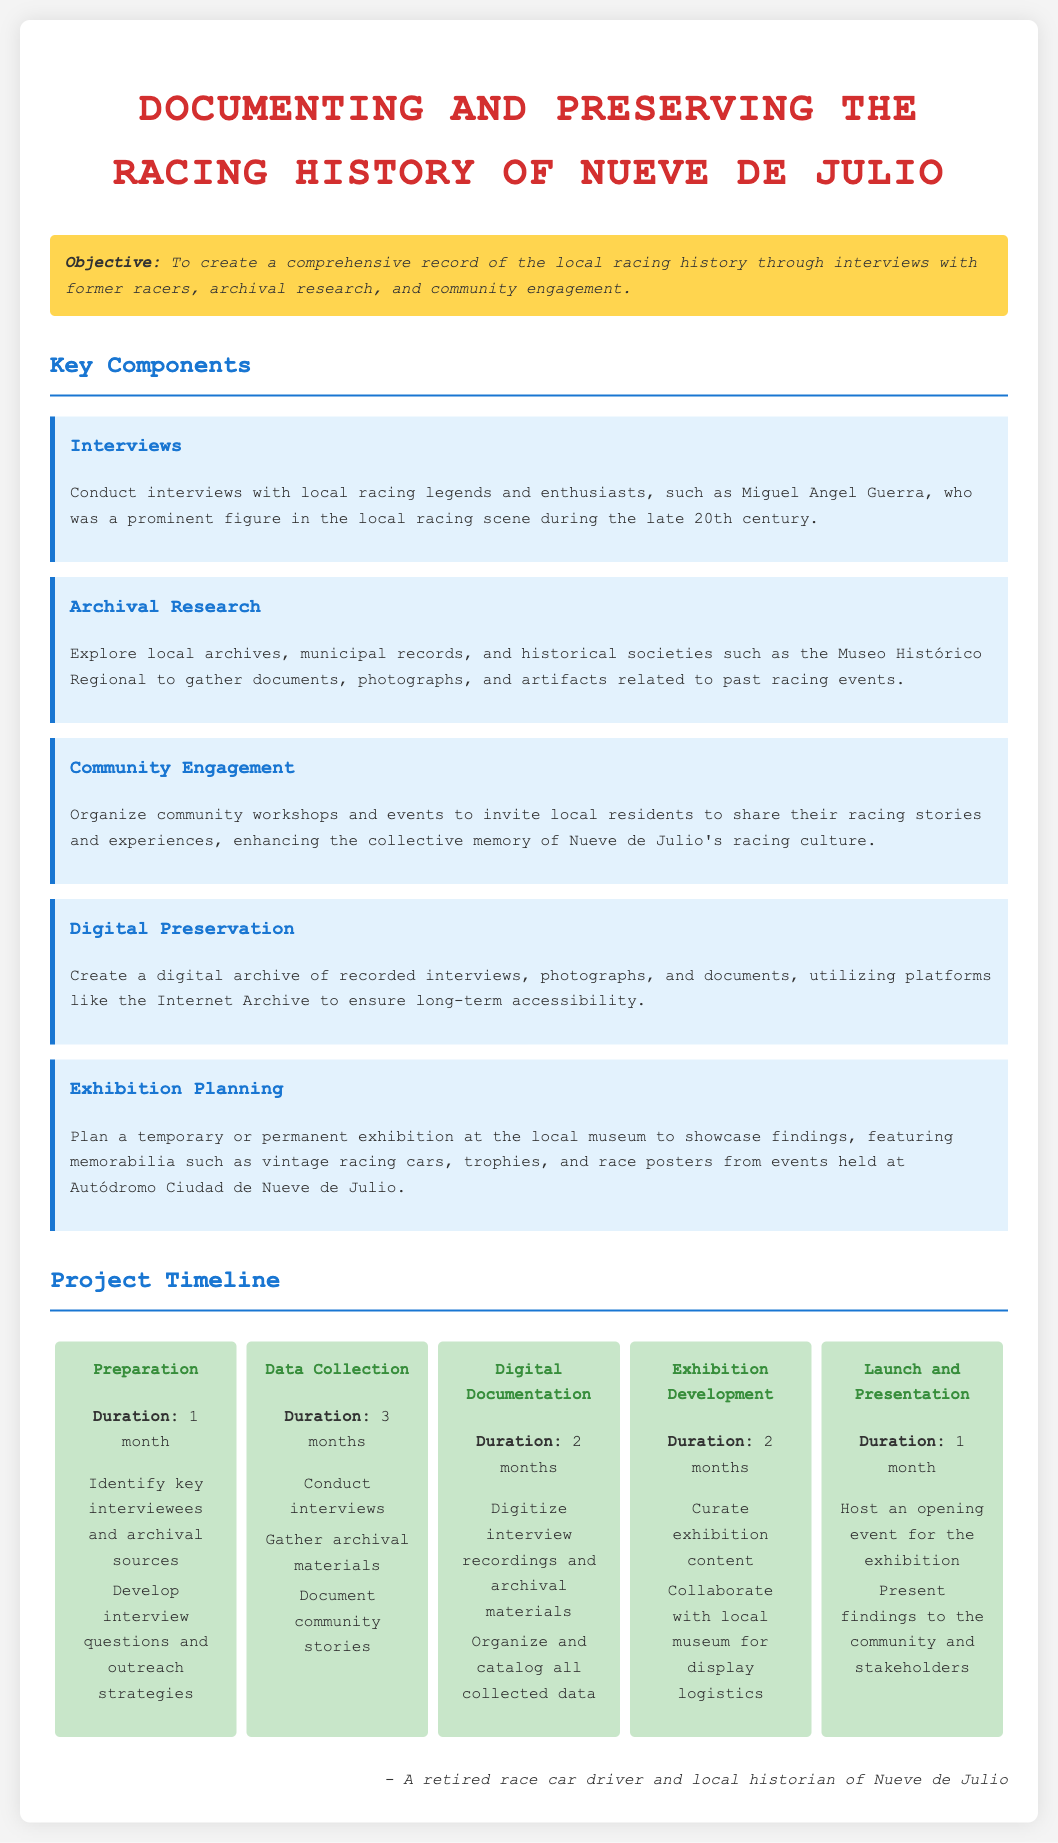What is the primary objective of the project? The primary objective is to create a comprehensive record of the local racing history through interviews, archival research, and community engagement.
Answer: To create a comprehensive record of the local racing history Who is a prominent figure mentioned for interviews? Miguel Angel Guerra is mentioned as a prominent figure in the local racing scene during the late 20th century.
Answer: Miguel Angel Guerra How long is the data collection phase? The data collection phase is specified to take place over three months.
Answer: 3 months What component involves local workshops? The component that involves local workshops is community engagement.
Answer: Community Engagement Where will the exhibition be showcased? The exhibition will be showcased at the local museum.
Answer: Local museum What is a digital preservation platform mentioned? The Internet Archive is mentioned as a platform for digital preservation.
Answer: Internet Archive What is the duration of the preparation phase? The preparation phase has a specified duration of one month.
Answer: 1 month How many components are listed in the document? There are five components listed in the document regarding the project.
Answer: Five components What is the final phase of the project timeline? The final phase of the project timeline is the launch and presentation.
Answer: Launch and Presentation 